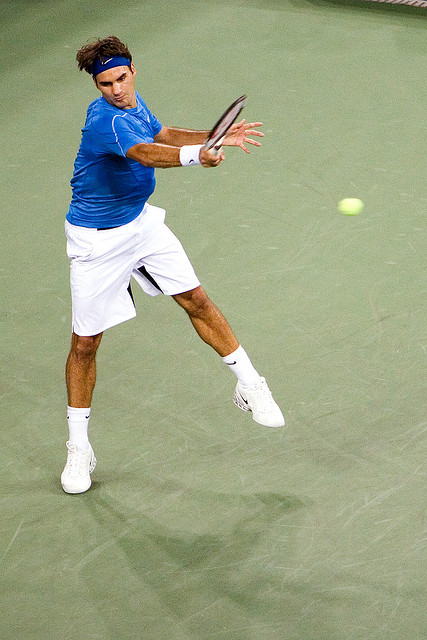<image>What are these man's emotions? It is unknown what the man's emotions are. His emotions could range from determination, focused on winning, competitive or intense. What are these man's emotions? I don't know what are these man's emotions. It can be seen concentration, competitive, energy, focused on winning, happy, intense, determination or none. 